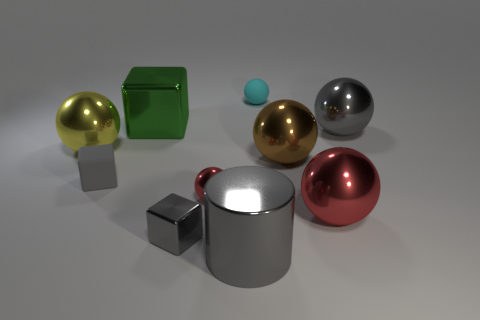How many red spheres must be subtracted to get 1 red spheres? 1 Subtract all brown balls. How many balls are left? 5 Subtract 2 balls. How many balls are left? 4 Subtract all big brown balls. How many balls are left? 5 Subtract all green spheres. Subtract all green cylinders. How many spheres are left? 6 Subtract all blocks. How many objects are left? 7 Add 3 small metal balls. How many small metal balls exist? 4 Subtract 0 blue blocks. How many objects are left? 10 Subtract all tiny metal cubes. Subtract all gray metallic objects. How many objects are left? 6 Add 7 rubber things. How many rubber things are left? 9 